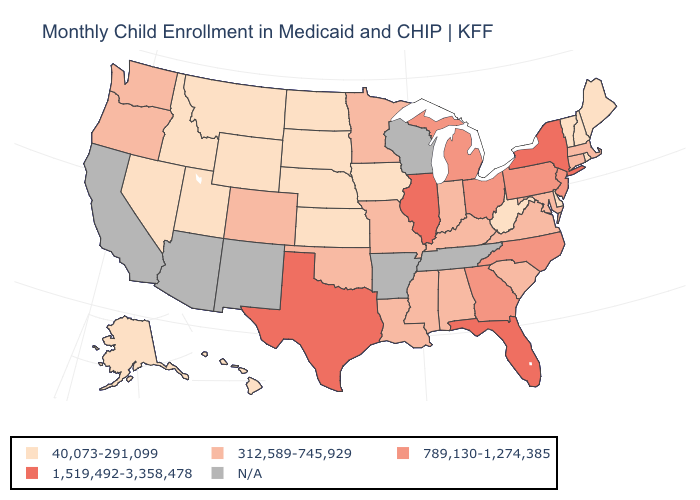Among the states that border Maryland , which have the lowest value?
Give a very brief answer. Delaware, West Virginia. What is the value of Kentucky?
Be succinct. 312,589-745,929. Name the states that have a value in the range 1,519,492-3,358,478?
Give a very brief answer. Florida, Illinois, New York, Texas. Among the states that border Georgia , does Florida have the highest value?
Be succinct. Yes. Which states have the lowest value in the South?
Answer briefly. Delaware, West Virginia. What is the value of Hawaii?
Keep it brief. 40,073-291,099. Name the states that have a value in the range 40,073-291,099?
Give a very brief answer. Alaska, Delaware, Hawaii, Idaho, Iowa, Kansas, Maine, Montana, Nebraska, Nevada, New Hampshire, North Dakota, Rhode Island, South Dakota, Utah, Vermont, West Virginia, Wyoming. What is the value of South Carolina?
Concise answer only. 312,589-745,929. What is the value of Texas?
Be succinct. 1,519,492-3,358,478. What is the value of Wyoming?
Answer briefly. 40,073-291,099. Among the states that border New Hampshire , does Vermont have the highest value?
Give a very brief answer. No. Does the map have missing data?
Short answer required. Yes. What is the value of Texas?
Answer briefly. 1,519,492-3,358,478. 